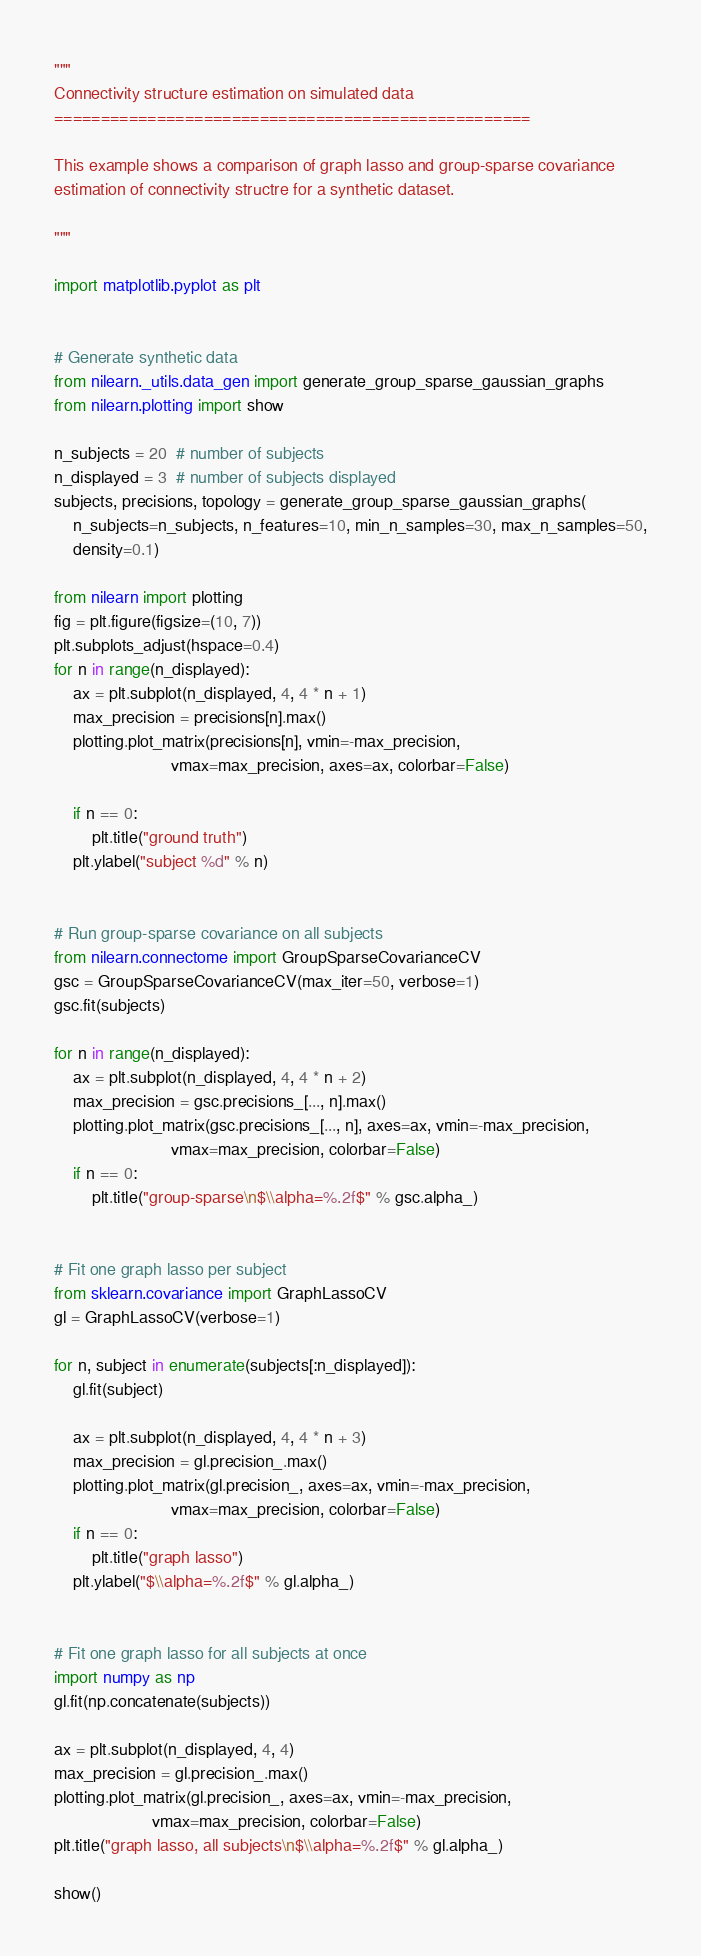Convert code to text. <code><loc_0><loc_0><loc_500><loc_500><_Python_>"""
Connectivity structure estimation on simulated data
===================================================

This example shows a comparison of graph lasso and group-sparse covariance
estimation of connectivity structre for a synthetic dataset.

"""

import matplotlib.pyplot as plt


# Generate synthetic data
from nilearn._utils.data_gen import generate_group_sparse_gaussian_graphs
from nilearn.plotting import show

n_subjects = 20  # number of subjects
n_displayed = 3  # number of subjects displayed
subjects, precisions, topology = generate_group_sparse_gaussian_graphs(
    n_subjects=n_subjects, n_features=10, min_n_samples=30, max_n_samples=50,
    density=0.1)

from nilearn import plotting
fig = plt.figure(figsize=(10, 7))
plt.subplots_adjust(hspace=0.4)
for n in range(n_displayed):
    ax = plt.subplot(n_displayed, 4, 4 * n + 1)
    max_precision = precisions[n].max()
    plotting.plot_matrix(precisions[n], vmin=-max_precision,
                         vmax=max_precision, axes=ax, colorbar=False)

    if n == 0:
        plt.title("ground truth")
    plt.ylabel("subject %d" % n)


# Run group-sparse covariance on all subjects
from nilearn.connectome import GroupSparseCovarianceCV
gsc = GroupSparseCovarianceCV(max_iter=50, verbose=1)
gsc.fit(subjects)

for n in range(n_displayed):
    ax = plt.subplot(n_displayed, 4, 4 * n + 2)
    max_precision = gsc.precisions_[..., n].max()
    plotting.plot_matrix(gsc.precisions_[..., n], axes=ax, vmin=-max_precision,
                         vmax=max_precision, colorbar=False)
    if n == 0:
        plt.title("group-sparse\n$\\alpha=%.2f$" % gsc.alpha_)


# Fit one graph lasso per subject
from sklearn.covariance import GraphLassoCV
gl = GraphLassoCV(verbose=1)

for n, subject in enumerate(subjects[:n_displayed]):
    gl.fit(subject)

    ax = plt.subplot(n_displayed, 4, 4 * n + 3)
    max_precision = gl.precision_.max()
    plotting.plot_matrix(gl.precision_, axes=ax, vmin=-max_precision,
                         vmax=max_precision, colorbar=False)
    if n == 0:
        plt.title("graph lasso")
    plt.ylabel("$\\alpha=%.2f$" % gl.alpha_)


# Fit one graph lasso for all subjects at once
import numpy as np
gl.fit(np.concatenate(subjects))

ax = plt.subplot(n_displayed, 4, 4)
max_precision = gl.precision_.max()
plotting.plot_matrix(gl.precision_, axes=ax, vmin=-max_precision,
                     vmax=max_precision, colorbar=False)
plt.title("graph lasso, all subjects\n$\\alpha=%.2f$" % gl.alpha_)

show()
</code> 